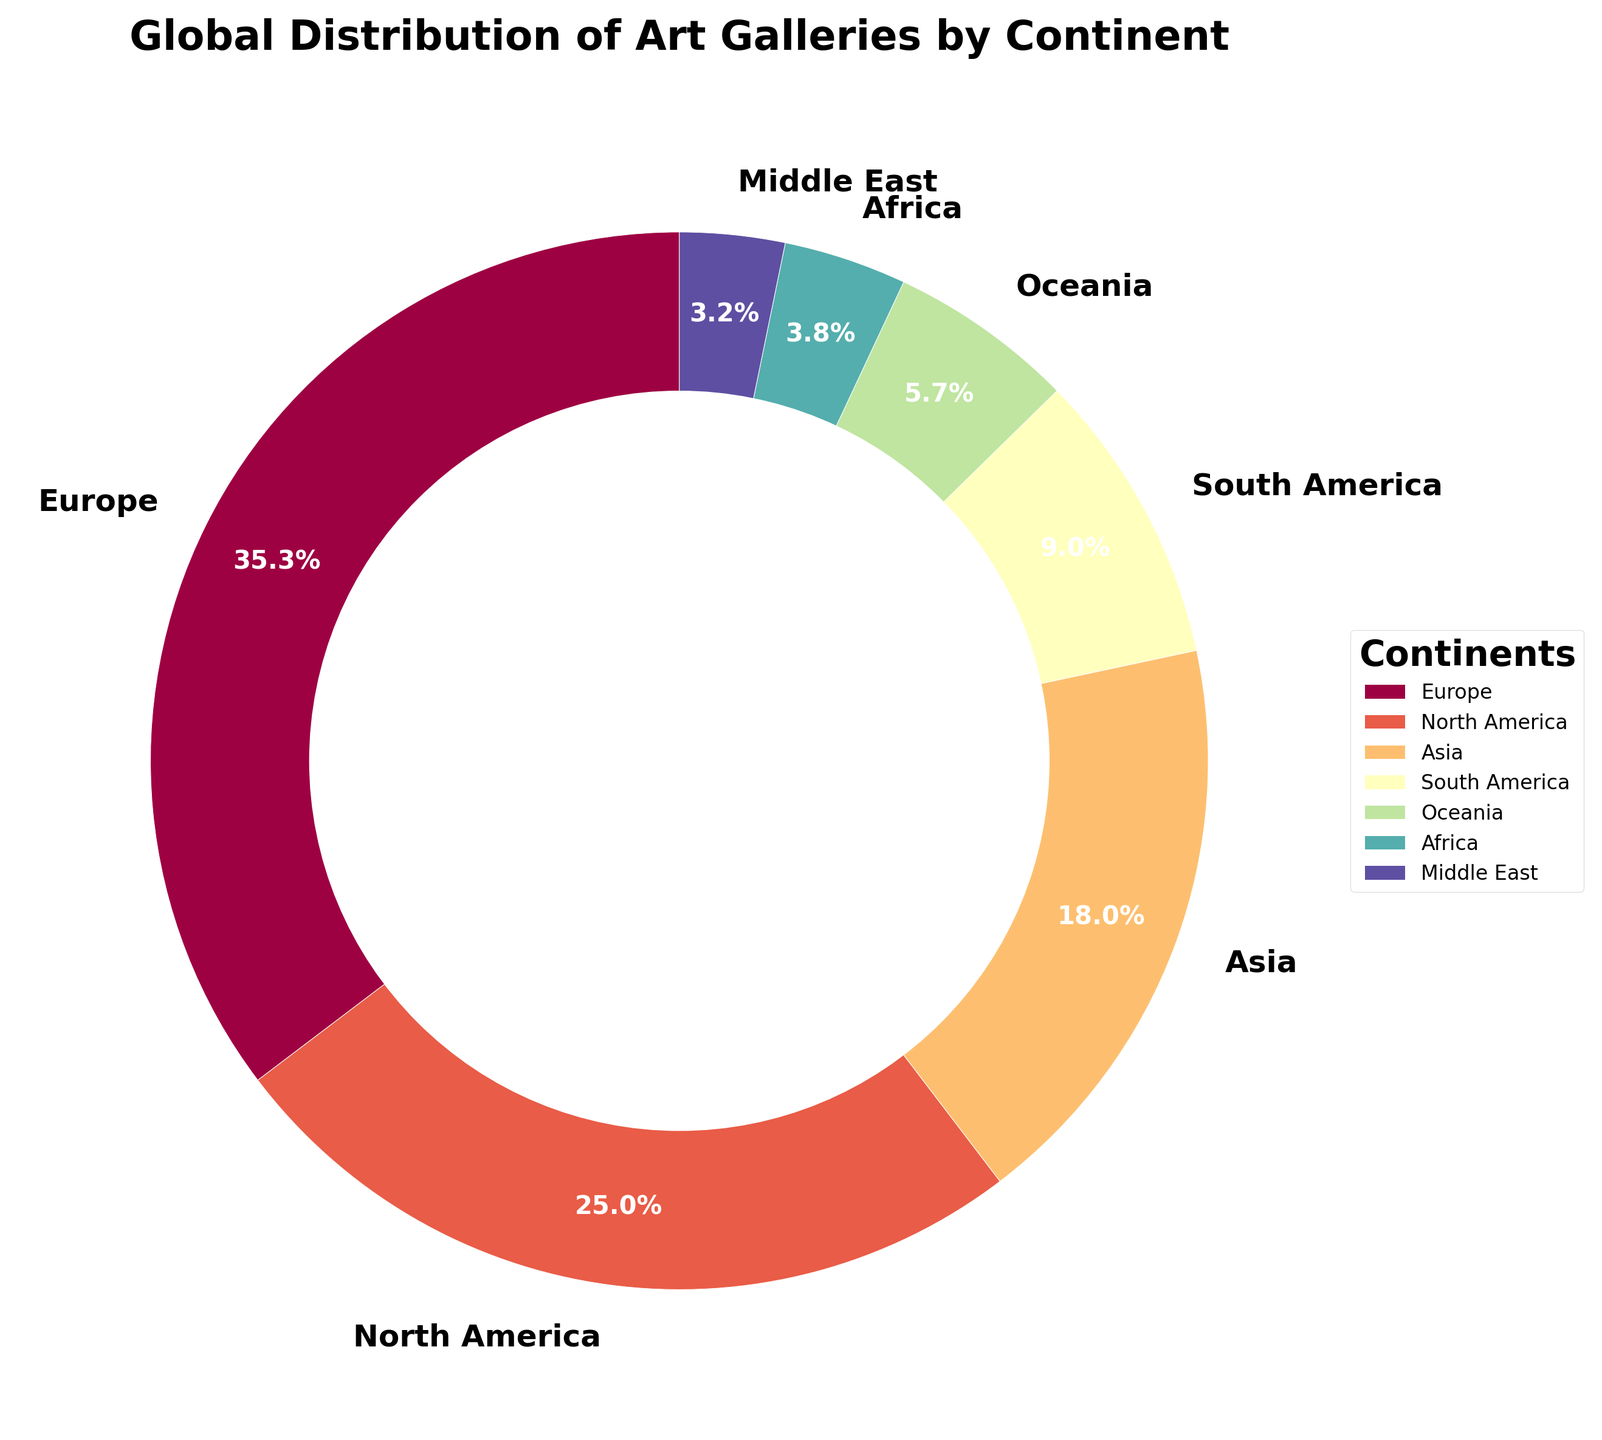What percentage of art galleries are located in Europe? The chart shows that 3850 galleries are in Europe out of a total of 10900 galleries globally. The percentage is (3850 / 10900) * 100 = 35.3%.
Answer: 35.3% Which continent has the second highest number of art galleries? North America has the second highest number of art galleries in the chart with 2730 galleries.
Answer: North America By how much does the number of art galleries in Asia exceed the combined number of galleries in Oceania and Africa? Asia has 1960 galleries, Oceania has 620, and Africa has 410 galleries. The combined number for Oceania and Africa is 620 + 410 = 1030. The difference is 1960 - 1030 = 930.
Answer: 930 Which four continents have the smallest number of art galleries? From the chart, the continents with the smallest number of art galleries are Africa (410), Middle East (350), Oceania (620), and South America (980).
Answer: Africa, Middle East, Oceania, South America If you were to group the continents into two categories (those with more than 1000 galleries and those with less than 1000 galleries), how many continents would fall in each category? The continents with more than 1000 galleries are Europe, North America, and Asia. Those with less than 1000 are South America, Oceania, Africa, and Middle East. Therefore, there are 3 continents with more than 1000 galleries and 4 with less.
Answer: 3, 4 Which two continents contribute to close to a quarter of all art galleries combined? North America and Asia combined (2730 + 1960 = 4690) have approximately (4690 / 10900) * 100 = 43.0%, meaning they together contribute close to half, not a quarter. The closest would be Asia and South America (2960 + 980 = 2940), contributing (2940/10900) * 100 ≈ 27.0%.
Answer: Asia, South America Are there more galleries in Oceania or Africa? The chart shows that Oceania has 620 galleries while Africa has 410 galleries. Therefore, Oceania has more.
Answer: Oceania What is the combined percentage of art galleries located in South America and the Middle East? South America has 980 galleries and Middle East has 350 galleries, combined they have 1330 galleries. The percentage is (1330/10900) * 100 ≈ 12.2%.
Answer: 12.2% 